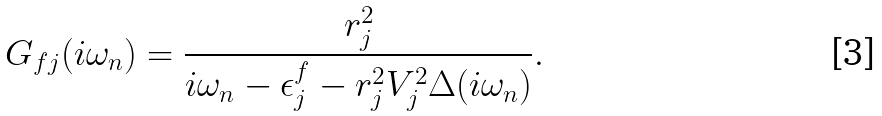<formula> <loc_0><loc_0><loc_500><loc_500>G _ { f j } ( i \omega _ { n } ) = \frac { r ^ { 2 } _ { j } } { i \omega _ { n } - \epsilon ^ { f } _ { j } - r ^ { 2 } _ { j } V ^ { 2 } _ { j } \Delta ( i \omega _ { n } ) } .</formula> 